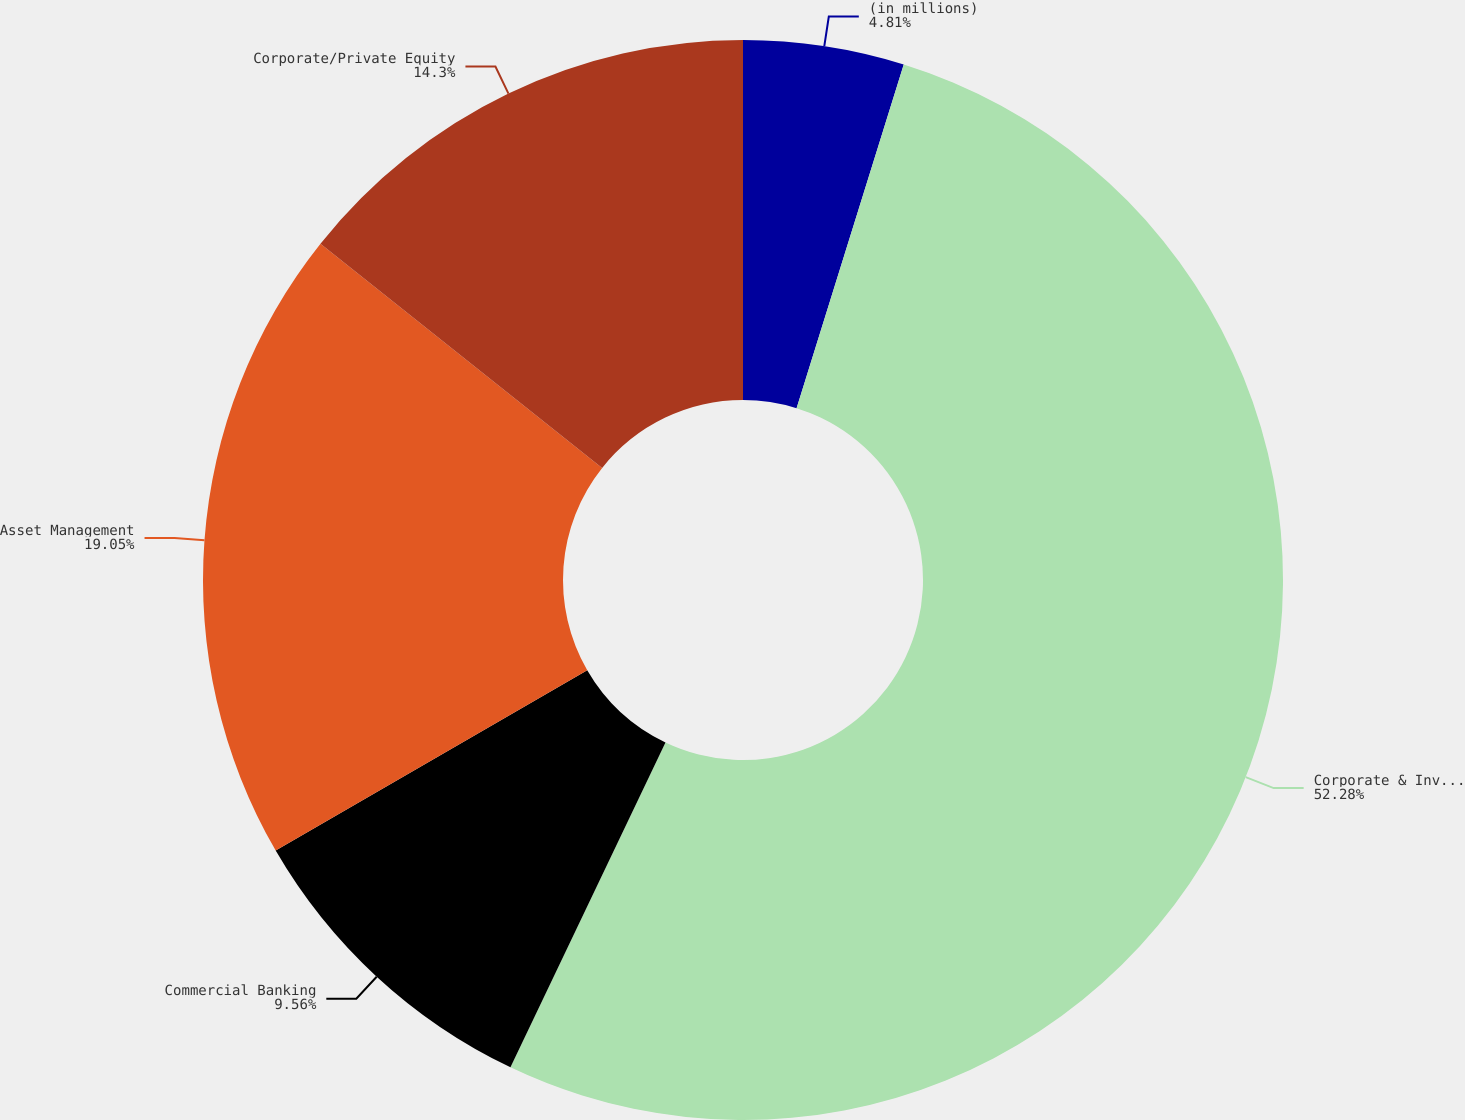Convert chart. <chart><loc_0><loc_0><loc_500><loc_500><pie_chart><fcel>(in millions)<fcel>Corporate & Investment Bank<fcel>Commercial Banking<fcel>Asset Management<fcel>Corporate/Private Equity<nl><fcel>4.81%<fcel>52.27%<fcel>9.56%<fcel>19.05%<fcel>14.3%<nl></chart> 